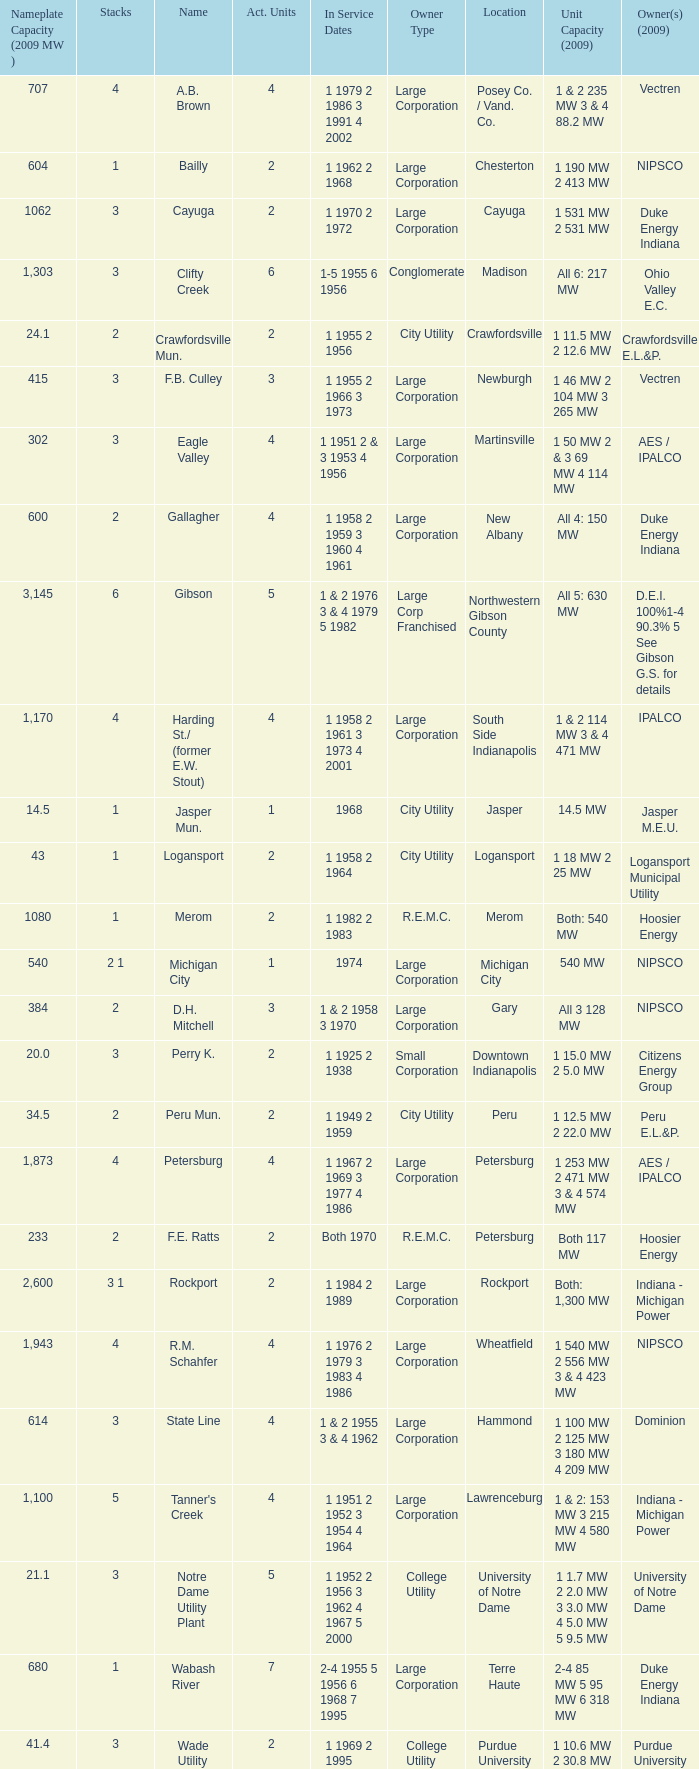What's the phone number to check on service dates for hoosier energy located in petersburg? 1.0. 